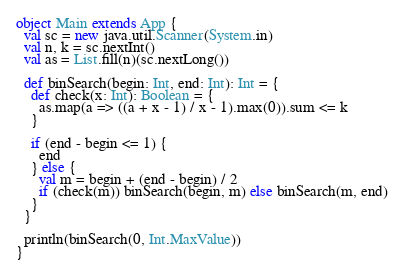Convert code to text. <code><loc_0><loc_0><loc_500><loc_500><_Scala_>object Main extends App {
  val sc = new java.util.Scanner(System.in)
  val n, k = sc.nextInt()
  val as = List.fill(n)(sc.nextLong())

  def binSearch(begin: Int, end: Int): Int = {
    def check(x: Int): Boolean = {
      as.map(a => ((a + x - 1) / x - 1).max(0)).sum <= k
    }

    if (end - begin <= 1) {
      end
    } else {
      val m = begin + (end - begin) / 2
      if (check(m)) binSearch(begin, m) else binSearch(m, end)
    }
  }

  println(binSearch(0, Int.MaxValue))
}
</code> 